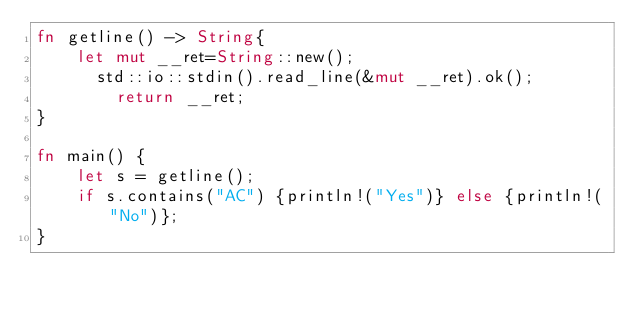<code> <loc_0><loc_0><loc_500><loc_500><_Rust_>fn getline() -> String{
    let mut __ret=String::new();
      std::io::stdin().read_line(&mut __ret).ok();
        return __ret;
}

fn main() {
    let s = getline();
    if s.contains("AC") {println!("Yes")} else {println!("No")};
}
</code> 